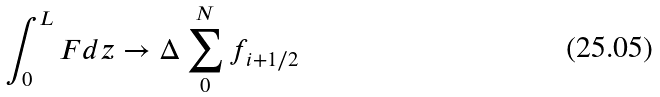<formula> <loc_0><loc_0><loc_500><loc_500>\int _ { 0 } ^ { L } F d z \rightarrow \Delta \sum _ { 0 } ^ { N } f _ { i + 1 / 2 }</formula> 